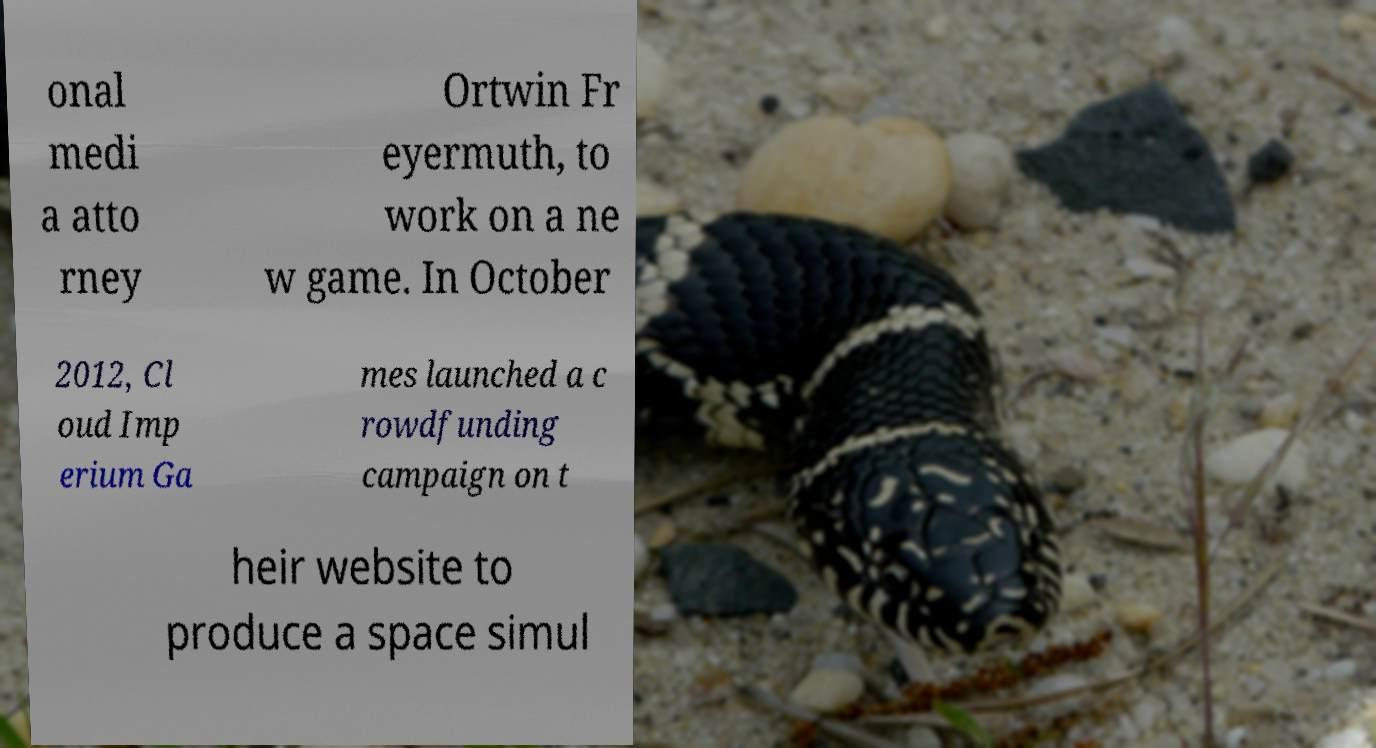I need the written content from this picture converted into text. Can you do that? onal medi a atto rney Ortwin Fr eyermuth, to work on a ne w game. In October 2012, Cl oud Imp erium Ga mes launched a c rowdfunding campaign on t heir website to produce a space simul 